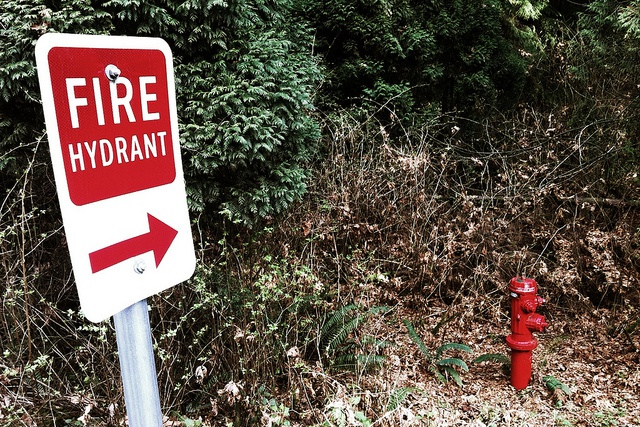Describe the objects in this image and their specific colors. I can see a fire hydrant in olive, brown, maroon, and black tones in this image. 